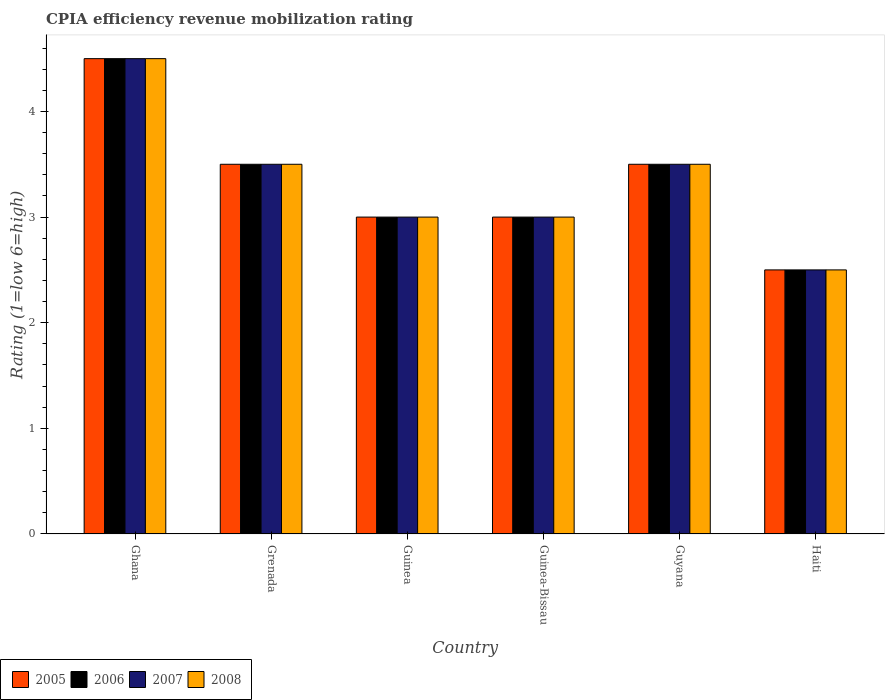Are the number of bars per tick equal to the number of legend labels?
Give a very brief answer. Yes. What is the label of the 2nd group of bars from the left?
Keep it short and to the point. Grenada. In how many cases, is the number of bars for a given country not equal to the number of legend labels?
Provide a short and direct response. 0. Across all countries, what is the minimum CPIA rating in 2007?
Ensure brevity in your answer.  2.5. In which country was the CPIA rating in 2005 maximum?
Your response must be concise. Ghana. In which country was the CPIA rating in 2006 minimum?
Keep it short and to the point. Haiti. What is the difference between the CPIA rating in 2006 in Ghana and that in Guinea-Bissau?
Provide a succinct answer. 1.5. What is the difference between the CPIA rating in 2008 in Grenada and the CPIA rating in 2005 in Guinea-Bissau?
Keep it short and to the point. 0.5. What is the average CPIA rating in 2008 per country?
Offer a terse response. 3.33. What is the difference between the CPIA rating of/in 2007 and CPIA rating of/in 2005 in Ghana?
Your answer should be very brief. 0. In how many countries, is the CPIA rating in 2008 greater than 0.8?
Offer a very short reply. 6. What is the ratio of the CPIA rating in 2007 in Guinea to that in Guyana?
Ensure brevity in your answer.  0.86. Is the difference between the CPIA rating in 2007 in Ghana and Haiti greater than the difference between the CPIA rating in 2005 in Ghana and Haiti?
Make the answer very short. No. What is the difference between the highest and the second highest CPIA rating in 2006?
Your answer should be very brief. -1. In how many countries, is the CPIA rating in 2008 greater than the average CPIA rating in 2008 taken over all countries?
Your response must be concise. 3. Is the sum of the CPIA rating in 2006 in Ghana and Grenada greater than the maximum CPIA rating in 2008 across all countries?
Your response must be concise. Yes. What does the 3rd bar from the left in Guyana represents?
Provide a short and direct response. 2007. What does the 2nd bar from the right in Grenada represents?
Offer a very short reply. 2007. Is it the case that in every country, the sum of the CPIA rating in 2008 and CPIA rating in 2005 is greater than the CPIA rating in 2006?
Your response must be concise. Yes. How many bars are there?
Offer a terse response. 24. How many countries are there in the graph?
Make the answer very short. 6. Does the graph contain any zero values?
Keep it short and to the point. No. Where does the legend appear in the graph?
Keep it short and to the point. Bottom left. How are the legend labels stacked?
Give a very brief answer. Horizontal. What is the title of the graph?
Offer a very short reply. CPIA efficiency revenue mobilization rating. Does "1977" appear as one of the legend labels in the graph?
Your answer should be very brief. No. What is the label or title of the Y-axis?
Your answer should be very brief. Rating (1=low 6=high). What is the Rating (1=low 6=high) of 2006 in Ghana?
Your response must be concise. 4.5. What is the Rating (1=low 6=high) of 2008 in Ghana?
Ensure brevity in your answer.  4.5. What is the Rating (1=low 6=high) in 2005 in Grenada?
Your answer should be compact. 3.5. What is the Rating (1=low 6=high) of 2006 in Grenada?
Provide a succinct answer. 3.5. What is the Rating (1=low 6=high) in 2007 in Grenada?
Provide a short and direct response. 3.5. What is the Rating (1=low 6=high) in 2008 in Grenada?
Your answer should be very brief. 3.5. What is the Rating (1=low 6=high) in 2008 in Guinea?
Give a very brief answer. 3. What is the Rating (1=low 6=high) in 2005 in Guinea-Bissau?
Your response must be concise. 3. What is the Rating (1=low 6=high) of 2008 in Guinea-Bissau?
Your response must be concise. 3. What is the Rating (1=low 6=high) of 2007 in Guyana?
Offer a terse response. 3.5. What is the Rating (1=low 6=high) of 2005 in Haiti?
Offer a terse response. 2.5. What is the Rating (1=low 6=high) in 2008 in Haiti?
Give a very brief answer. 2.5. Across all countries, what is the minimum Rating (1=low 6=high) in 2005?
Offer a very short reply. 2.5. Across all countries, what is the minimum Rating (1=low 6=high) of 2008?
Make the answer very short. 2.5. What is the total Rating (1=low 6=high) of 2006 in the graph?
Keep it short and to the point. 20. What is the total Rating (1=low 6=high) of 2007 in the graph?
Give a very brief answer. 20. What is the difference between the Rating (1=low 6=high) in 2005 in Ghana and that in Grenada?
Keep it short and to the point. 1. What is the difference between the Rating (1=low 6=high) in 2006 in Ghana and that in Grenada?
Ensure brevity in your answer.  1. What is the difference between the Rating (1=low 6=high) of 2008 in Ghana and that in Grenada?
Keep it short and to the point. 1. What is the difference between the Rating (1=low 6=high) of 2008 in Ghana and that in Guinea?
Your answer should be very brief. 1.5. What is the difference between the Rating (1=low 6=high) in 2006 in Ghana and that in Guinea-Bissau?
Offer a very short reply. 1.5. What is the difference between the Rating (1=low 6=high) of 2007 in Ghana and that in Guinea-Bissau?
Give a very brief answer. 1.5. What is the difference between the Rating (1=low 6=high) of 2008 in Ghana and that in Guinea-Bissau?
Your answer should be very brief. 1.5. What is the difference between the Rating (1=low 6=high) in 2005 in Ghana and that in Guyana?
Make the answer very short. 1. What is the difference between the Rating (1=low 6=high) of 2007 in Ghana and that in Guyana?
Provide a succinct answer. 1. What is the difference between the Rating (1=low 6=high) of 2005 in Ghana and that in Haiti?
Give a very brief answer. 2. What is the difference between the Rating (1=low 6=high) of 2007 in Ghana and that in Haiti?
Your answer should be very brief. 2. What is the difference between the Rating (1=low 6=high) in 2008 in Ghana and that in Haiti?
Your answer should be compact. 2. What is the difference between the Rating (1=low 6=high) of 2005 in Grenada and that in Guinea?
Give a very brief answer. 0.5. What is the difference between the Rating (1=low 6=high) in 2007 in Grenada and that in Guinea?
Ensure brevity in your answer.  0.5. What is the difference between the Rating (1=low 6=high) of 2006 in Grenada and that in Guinea-Bissau?
Offer a very short reply. 0.5. What is the difference between the Rating (1=low 6=high) of 2007 in Grenada and that in Guinea-Bissau?
Your answer should be very brief. 0.5. What is the difference between the Rating (1=low 6=high) of 2006 in Grenada and that in Guyana?
Your answer should be compact. 0. What is the difference between the Rating (1=low 6=high) in 2005 in Grenada and that in Haiti?
Your answer should be compact. 1. What is the difference between the Rating (1=low 6=high) in 2007 in Grenada and that in Haiti?
Offer a very short reply. 1. What is the difference between the Rating (1=low 6=high) in 2008 in Grenada and that in Haiti?
Provide a short and direct response. 1. What is the difference between the Rating (1=low 6=high) in 2006 in Guinea and that in Guinea-Bissau?
Provide a short and direct response. 0. What is the difference between the Rating (1=low 6=high) of 2007 in Guinea and that in Guinea-Bissau?
Your answer should be very brief. 0. What is the difference between the Rating (1=low 6=high) of 2008 in Guinea and that in Guinea-Bissau?
Offer a terse response. 0. What is the difference between the Rating (1=low 6=high) in 2005 in Guinea and that in Guyana?
Your answer should be compact. -0.5. What is the difference between the Rating (1=low 6=high) in 2006 in Guinea and that in Guyana?
Ensure brevity in your answer.  -0.5. What is the difference between the Rating (1=low 6=high) of 2007 in Guinea and that in Guyana?
Your response must be concise. -0.5. What is the difference between the Rating (1=low 6=high) in 2008 in Guinea and that in Guyana?
Keep it short and to the point. -0.5. What is the difference between the Rating (1=low 6=high) in 2006 in Guinea and that in Haiti?
Offer a very short reply. 0.5. What is the difference between the Rating (1=low 6=high) in 2007 in Guinea and that in Haiti?
Provide a succinct answer. 0.5. What is the difference between the Rating (1=low 6=high) in 2008 in Guinea and that in Haiti?
Offer a terse response. 0.5. What is the difference between the Rating (1=low 6=high) in 2005 in Guinea-Bissau and that in Guyana?
Your answer should be compact. -0.5. What is the difference between the Rating (1=low 6=high) in 2006 in Guinea-Bissau and that in Guyana?
Offer a very short reply. -0.5. What is the difference between the Rating (1=low 6=high) in 2008 in Guinea-Bissau and that in Haiti?
Keep it short and to the point. 0.5. What is the difference between the Rating (1=low 6=high) of 2005 in Guyana and that in Haiti?
Provide a succinct answer. 1. What is the difference between the Rating (1=low 6=high) in 2008 in Guyana and that in Haiti?
Give a very brief answer. 1. What is the difference between the Rating (1=low 6=high) in 2005 in Ghana and the Rating (1=low 6=high) in 2006 in Grenada?
Your answer should be compact. 1. What is the difference between the Rating (1=low 6=high) of 2005 in Ghana and the Rating (1=low 6=high) of 2007 in Grenada?
Offer a very short reply. 1. What is the difference between the Rating (1=low 6=high) in 2005 in Ghana and the Rating (1=low 6=high) in 2008 in Grenada?
Give a very brief answer. 1. What is the difference between the Rating (1=low 6=high) of 2007 in Ghana and the Rating (1=low 6=high) of 2008 in Grenada?
Give a very brief answer. 1. What is the difference between the Rating (1=low 6=high) of 2006 in Ghana and the Rating (1=low 6=high) of 2007 in Guinea?
Ensure brevity in your answer.  1.5. What is the difference between the Rating (1=low 6=high) in 2006 in Ghana and the Rating (1=low 6=high) in 2008 in Guinea?
Keep it short and to the point. 1.5. What is the difference between the Rating (1=low 6=high) in 2007 in Ghana and the Rating (1=low 6=high) in 2008 in Guinea?
Offer a terse response. 1.5. What is the difference between the Rating (1=low 6=high) in 2005 in Ghana and the Rating (1=low 6=high) in 2007 in Guinea-Bissau?
Make the answer very short. 1.5. What is the difference between the Rating (1=low 6=high) of 2005 in Ghana and the Rating (1=low 6=high) of 2008 in Guinea-Bissau?
Provide a short and direct response. 1.5. What is the difference between the Rating (1=low 6=high) of 2005 in Ghana and the Rating (1=low 6=high) of 2006 in Guyana?
Your answer should be very brief. 1. What is the difference between the Rating (1=low 6=high) of 2005 in Ghana and the Rating (1=low 6=high) of 2007 in Guyana?
Offer a terse response. 1. What is the difference between the Rating (1=low 6=high) of 2005 in Ghana and the Rating (1=low 6=high) of 2008 in Guyana?
Keep it short and to the point. 1. What is the difference between the Rating (1=low 6=high) in 2006 in Ghana and the Rating (1=low 6=high) in 2007 in Guyana?
Provide a short and direct response. 1. What is the difference between the Rating (1=low 6=high) of 2006 in Ghana and the Rating (1=low 6=high) of 2008 in Guyana?
Make the answer very short. 1. What is the difference between the Rating (1=low 6=high) in 2007 in Ghana and the Rating (1=low 6=high) in 2008 in Guyana?
Your answer should be very brief. 1. What is the difference between the Rating (1=low 6=high) of 2005 in Ghana and the Rating (1=low 6=high) of 2007 in Haiti?
Provide a succinct answer. 2. What is the difference between the Rating (1=low 6=high) of 2005 in Ghana and the Rating (1=low 6=high) of 2008 in Haiti?
Make the answer very short. 2. What is the difference between the Rating (1=low 6=high) in 2006 in Ghana and the Rating (1=low 6=high) in 2007 in Haiti?
Keep it short and to the point. 2. What is the difference between the Rating (1=low 6=high) in 2007 in Ghana and the Rating (1=low 6=high) in 2008 in Haiti?
Your answer should be very brief. 2. What is the difference between the Rating (1=low 6=high) of 2005 in Grenada and the Rating (1=low 6=high) of 2008 in Guinea?
Offer a very short reply. 0.5. What is the difference between the Rating (1=low 6=high) in 2006 in Grenada and the Rating (1=low 6=high) in 2007 in Guinea?
Your answer should be very brief. 0.5. What is the difference between the Rating (1=low 6=high) of 2005 in Grenada and the Rating (1=low 6=high) of 2006 in Guinea-Bissau?
Provide a succinct answer. 0.5. What is the difference between the Rating (1=low 6=high) of 2005 in Grenada and the Rating (1=low 6=high) of 2007 in Guinea-Bissau?
Keep it short and to the point. 0.5. What is the difference between the Rating (1=low 6=high) of 2006 in Grenada and the Rating (1=low 6=high) of 2008 in Guinea-Bissau?
Give a very brief answer. 0.5. What is the difference between the Rating (1=low 6=high) in 2005 in Grenada and the Rating (1=low 6=high) in 2006 in Guyana?
Offer a terse response. 0. What is the difference between the Rating (1=low 6=high) of 2007 in Grenada and the Rating (1=low 6=high) of 2008 in Guyana?
Make the answer very short. 0. What is the difference between the Rating (1=low 6=high) of 2005 in Grenada and the Rating (1=low 6=high) of 2006 in Haiti?
Provide a succinct answer. 1. What is the difference between the Rating (1=low 6=high) in 2005 in Grenada and the Rating (1=low 6=high) in 2008 in Haiti?
Keep it short and to the point. 1. What is the difference between the Rating (1=low 6=high) in 2006 in Grenada and the Rating (1=low 6=high) in 2007 in Haiti?
Your answer should be compact. 1. What is the difference between the Rating (1=low 6=high) in 2005 in Guinea and the Rating (1=low 6=high) in 2006 in Guinea-Bissau?
Offer a terse response. 0. What is the difference between the Rating (1=low 6=high) of 2005 in Guinea and the Rating (1=low 6=high) of 2008 in Guinea-Bissau?
Your answer should be very brief. 0. What is the difference between the Rating (1=low 6=high) in 2006 in Guinea and the Rating (1=low 6=high) in 2007 in Guinea-Bissau?
Give a very brief answer. 0. What is the difference between the Rating (1=low 6=high) in 2006 in Guinea and the Rating (1=low 6=high) in 2008 in Guinea-Bissau?
Offer a very short reply. 0. What is the difference between the Rating (1=low 6=high) in 2007 in Guinea and the Rating (1=low 6=high) in 2008 in Guinea-Bissau?
Offer a very short reply. 0. What is the difference between the Rating (1=low 6=high) of 2005 in Guinea and the Rating (1=low 6=high) of 2007 in Guyana?
Your response must be concise. -0.5. What is the difference between the Rating (1=low 6=high) of 2005 in Guinea and the Rating (1=low 6=high) of 2008 in Guyana?
Ensure brevity in your answer.  -0.5. What is the difference between the Rating (1=low 6=high) of 2006 in Guinea and the Rating (1=low 6=high) of 2008 in Guyana?
Your response must be concise. -0.5. What is the difference between the Rating (1=low 6=high) of 2005 in Guinea and the Rating (1=low 6=high) of 2006 in Haiti?
Offer a terse response. 0.5. What is the difference between the Rating (1=low 6=high) of 2005 in Guinea and the Rating (1=low 6=high) of 2008 in Haiti?
Ensure brevity in your answer.  0.5. What is the difference between the Rating (1=low 6=high) of 2006 in Guinea and the Rating (1=low 6=high) of 2008 in Haiti?
Your answer should be compact. 0.5. What is the difference between the Rating (1=low 6=high) in 2005 in Guinea-Bissau and the Rating (1=low 6=high) in 2007 in Guyana?
Offer a very short reply. -0.5. What is the difference between the Rating (1=low 6=high) of 2005 in Guinea-Bissau and the Rating (1=low 6=high) of 2008 in Guyana?
Give a very brief answer. -0.5. What is the difference between the Rating (1=low 6=high) of 2006 in Guinea-Bissau and the Rating (1=low 6=high) of 2008 in Guyana?
Offer a very short reply. -0.5. What is the difference between the Rating (1=low 6=high) of 2007 in Guinea-Bissau and the Rating (1=low 6=high) of 2008 in Guyana?
Your answer should be compact. -0.5. What is the difference between the Rating (1=low 6=high) of 2005 in Guinea-Bissau and the Rating (1=low 6=high) of 2006 in Haiti?
Provide a succinct answer. 0.5. What is the difference between the Rating (1=low 6=high) of 2005 in Guinea-Bissau and the Rating (1=low 6=high) of 2007 in Haiti?
Offer a terse response. 0.5. What is the difference between the Rating (1=low 6=high) in 2006 in Guinea-Bissau and the Rating (1=low 6=high) in 2008 in Haiti?
Give a very brief answer. 0.5. What is the difference between the Rating (1=low 6=high) of 2005 in Guyana and the Rating (1=low 6=high) of 2006 in Haiti?
Keep it short and to the point. 1. What is the difference between the Rating (1=low 6=high) in 2005 in Guyana and the Rating (1=low 6=high) in 2007 in Haiti?
Provide a succinct answer. 1. What is the difference between the Rating (1=low 6=high) in 2005 in Guyana and the Rating (1=low 6=high) in 2008 in Haiti?
Your response must be concise. 1. What is the difference between the Rating (1=low 6=high) in 2006 in Guyana and the Rating (1=low 6=high) in 2007 in Haiti?
Your answer should be very brief. 1. What is the difference between the Rating (1=low 6=high) of 2006 in Guyana and the Rating (1=low 6=high) of 2008 in Haiti?
Offer a very short reply. 1. What is the average Rating (1=low 6=high) in 2005 per country?
Make the answer very short. 3.33. What is the average Rating (1=low 6=high) in 2006 per country?
Your response must be concise. 3.33. What is the difference between the Rating (1=low 6=high) in 2005 and Rating (1=low 6=high) in 2008 in Ghana?
Make the answer very short. 0. What is the difference between the Rating (1=low 6=high) of 2006 and Rating (1=low 6=high) of 2007 in Ghana?
Your answer should be compact. 0. What is the difference between the Rating (1=low 6=high) of 2005 and Rating (1=low 6=high) of 2006 in Grenada?
Offer a very short reply. 0. What is the difference between the Rating (1=low 6=high) of 2005 and Rating (1=low 6=high) of 2007 in Grenada?
Your answer should be very brief. 0. What is the difference between the Rating (1=low 6=high) in 2005 and Rating (1=low 6=high) in 2008 in Grenada?
Your answer should be very brief. 0. What is the difference between the Rating (1=low 6=high) in 2006 and Rating (1=low 6=high) in 2008 in Grenada?
Your answer should be very brief. 0. What is the difference between the Rating (1=low 6=high) in 2005 and Rating (1=low 6=high) in 2006 in Guinea-Bissau?
Your answer should be compact. 0. What is the difference between the Rating (1=low 6=high) of 2005 and Rating (1=low 6=high) of 2007 in Guinea-Bissau?
Your answer should be very brief. 0. What is the difference between the Rating (1=low 6=high) of 2005 and Rating (1=low 6=high) of 2008 in Guinea-Bissau?
Your answer should be compact. 0. What is the difference between the Rating (1=low 6=high) in 2006 and Rating (1=low 6=high) in 2007 in Guinea-Bissau?
Make the answer very short. 0. What is the difference between the Rating (1=low 6=high) in 2006 and Rating (1=low 6=high) in 2008 in Guinea-Bissau?
Ensure brevity in your answer.  0. What is the difference between the Rating (1=low 6=high) of 2005 and Rating (1=low 6=high) of 2007 in Guyana?
Your answer should be very brief. 0. What is the difference between the Rating (1=low 6=high) in 2006 and Rating (1=low 6=high) in 2008 in Guyana?
Your response must be concise. 0. What is the difference between the Rating (1=low 6=high) in 2005 and Rating (1=low 6=high) in 2008 in Haiti?
Offer a very short reply. 0. What is the difference between the Rating (1=low 6=high) of 2006 and Rating (1=low 6=high) of 2007 in Haiti?
Ensure brevity in your answer.  0. What is the difference between the Rating (1=low 6=high) in 2006 and Rating (1=low 6=high) in 2008 in Haiti?
Keep it short and to the point. 0. What is the ratio of the Rating (1=low 6=high) in 2006 in Ghana to that in Grenada?
Your answer should be compact. 1.29. What is the ratio of the Rating (1=low 6=high) of 2007 in Ghana to that in Grenada?
Make the answer very short. 1.29. What is the ratio of the Rating (1=low 6=high) in 2005 in Ghana to that in Guinea?
Provide a succinct answer. 1.5. What is the ratio of the Rating (1=low 6=high) of 2008 in Ghana to that in Guinea?
Give a very brief answer. 1.5. What is the ratio of the Rating (1=low 6=high) of 2005 in Ghana to that in Guinea-Bissau?
Give a very brief answer. 1.5. What is the ratio of the Rating (1=low 6=high) of 2007 in Ghana to that in Guinea-Bissau?
Your response must be concise. 1.5. What is the ratio of the Rating (1=low 6=high) of 2006 in Ghana to that in Guyana?
Provide a short and direct response. 1.29. What is the ratio of the Rating (1=low 6=high) of 2007 in Ghana to that in Guyana?
Keep it short and to the point. 1.29. What is the ratio of the Rating (1=low 6=high) in 2007 in Grenada to that in Guinea?
Offer a very short reply. 1.17. What is the ratio of the Rating (1=low 6=high) of 2005 in Grenada to that in Guyana?
Your answer should be very brief. 1. What is the ratio of the Rating (1=low 6=high) of 2007 in Grenada to that in Guyana?
Give a very brief answer. 1. What is the ratio of the Rating (1=low 6=high) of 2008 in Grenada to that in Haiti?
Provide a succinct answer. 1.4. What is the ratio of the Rating (1=low 6=high) of 2005 in Guinea to that in Guinea-Bissau?
Ensure brevity in your answer.  1. What is the ratio of the Rating (1=low 6=high) of 2005 in Guinea to that in Guyana?
Keep it short and to the point. 0.86. What is the ratio of the Rating (1=low 6=high) in 2005 in Guinea to that in Haiti?
Keep it short and to the point. 1.2. What is the ratio of the Rating (1=low 6=high) in 2006 in Guinea-Bissau to that in Guyana?
Give a very brief answer. 0.86. What is the ratio of the Rating (1=low 6=high) in 2007 in Guinea-Bissau to that in Haiti?
Provide a succinct answer. 1.2. What is the ratio of the Rating (1=low 6=high) in 2008 in Guinea-Bissau to that in Haiti?
Make the answer very short. 1.2. What is the difference between the highest and the second highest Rating (1=low 6=high) in 2006?
Offer a very short reply. 1. What is the difference between the highest and the second highest Rating (1=low 6=high) of 2007?
Your answer should be very brief. 1. What is the difference between the highest and the lowest Rating (1=low 6=high) of 2008?
Offer a very short reply. 2. 